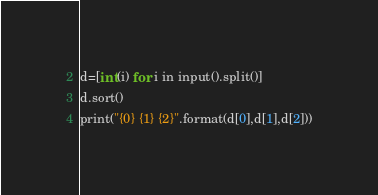Convert code to text. <code><loc_0><loc_0><loc_500><loc_500><_C_>d=[int(i) for i in input().split()]
d.sort()
print("{0} {1} {2}".format(d[0],d[1],d[2]))</code> 